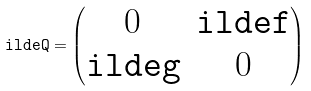<formula> <loc_0><loc_0><loc_500><loc_500>\tt i l d e Q = \begin{pmatrix} 0 & \tt i l d e f \\ \tt i l d e g & 0 \end{pmatrix}</formula> 